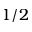Convert formula to latex. <formula><loc_0><loc_0><loc_500><loc_500>1 / 2</formula> 